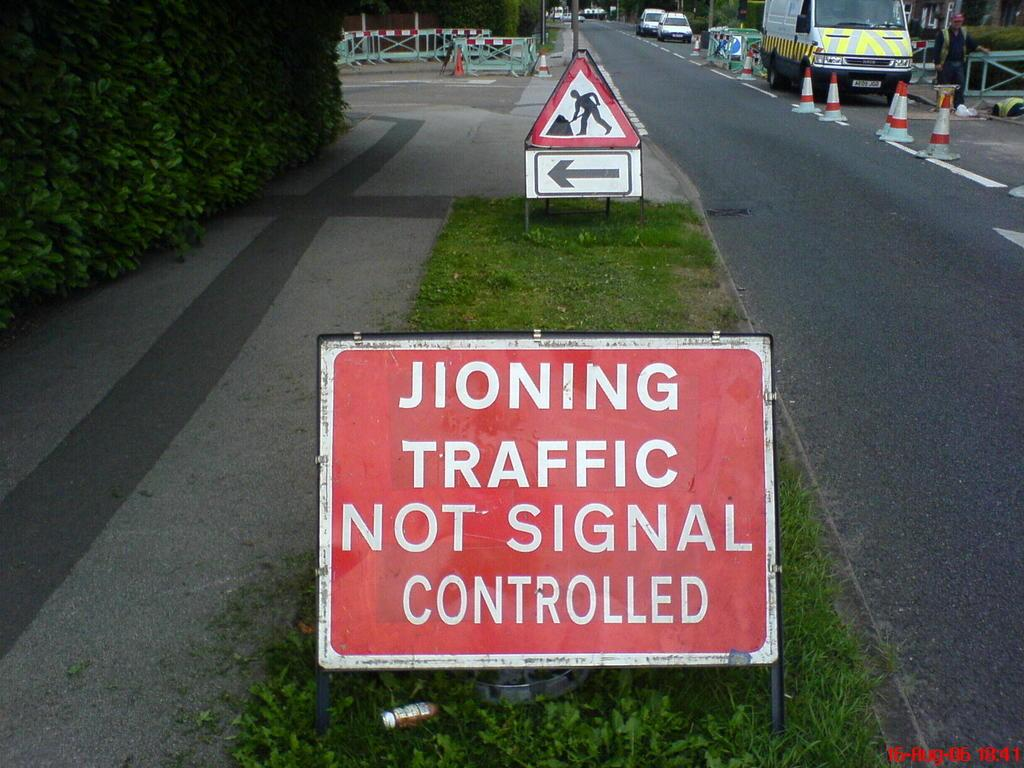Provide a one-sentence caption for the provided image. A road containing roadworks and a sign which is mispelled concerning "JIONING TRAFFIC". 